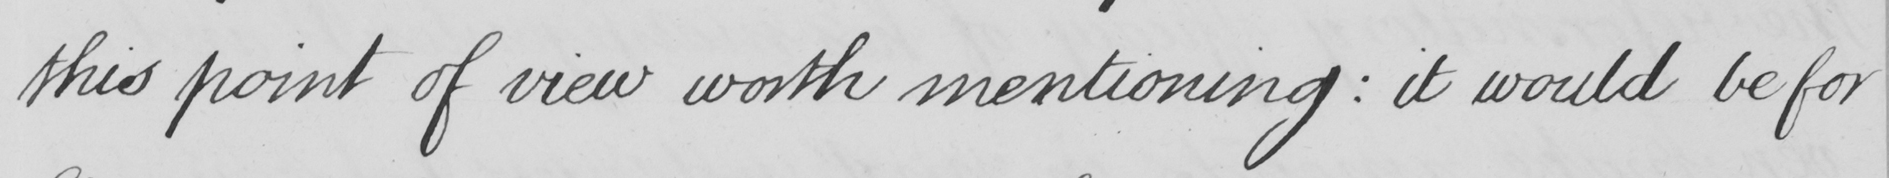Can you read and transcribe this handwriting? this point of view worth mentioning :  it would be for 